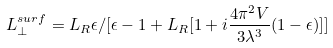<formula> <loc_0><loc_0><loc_500><loc_500>L _ { \perp } ^ { s u r f } = L _ { R } \epsilon / [ \epsilon - 1 + L _ { R } [ 1 + i \frac { 4 \pi ^ { 2 } V } { 3 \lambda ^ { 3 } } ( 1 - \epsilon ) ] ]</formula> 